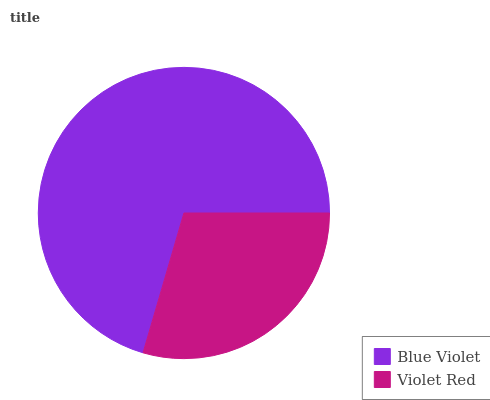Is Violet Red the minimum?
Answer yes or no. Yes. Is Blue Violet the maximum?
Answer yes or no. Yes. Is Violet Red the maximum?
Answer yes or no. No. Is Blue Violet greater than Violet Red?
Answer yes or no. Yes. Is Violet Red less than Blue Violet?
Answer yes or no. Yes. Is Violet Red greater than Blue Violet?
Answer yes or no. No. Is Blue Violet less than Violet Red?
Answer yes or no. No. Is Blue Violet the high median?
Answer yes or no. Yes. Is Violet Red the low median?
Answer yes or no. Yes. Is Violet Red the high median?
Answer yes or no. No. Is Blue Violet the low median?
Answer yes or no. No. 